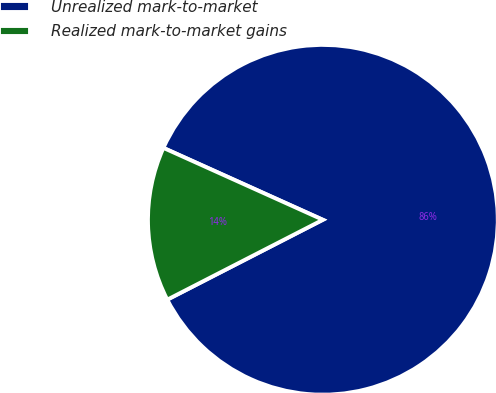Convert chart. <chart><loc_0><loc_0><loc_500><loc_500><pie_chart><fcel>Unrealized mark-to-market<fcel>Realized mark-to-market gains<nl><fcel>85.71%<fcel>14.29%<nl></chart> 